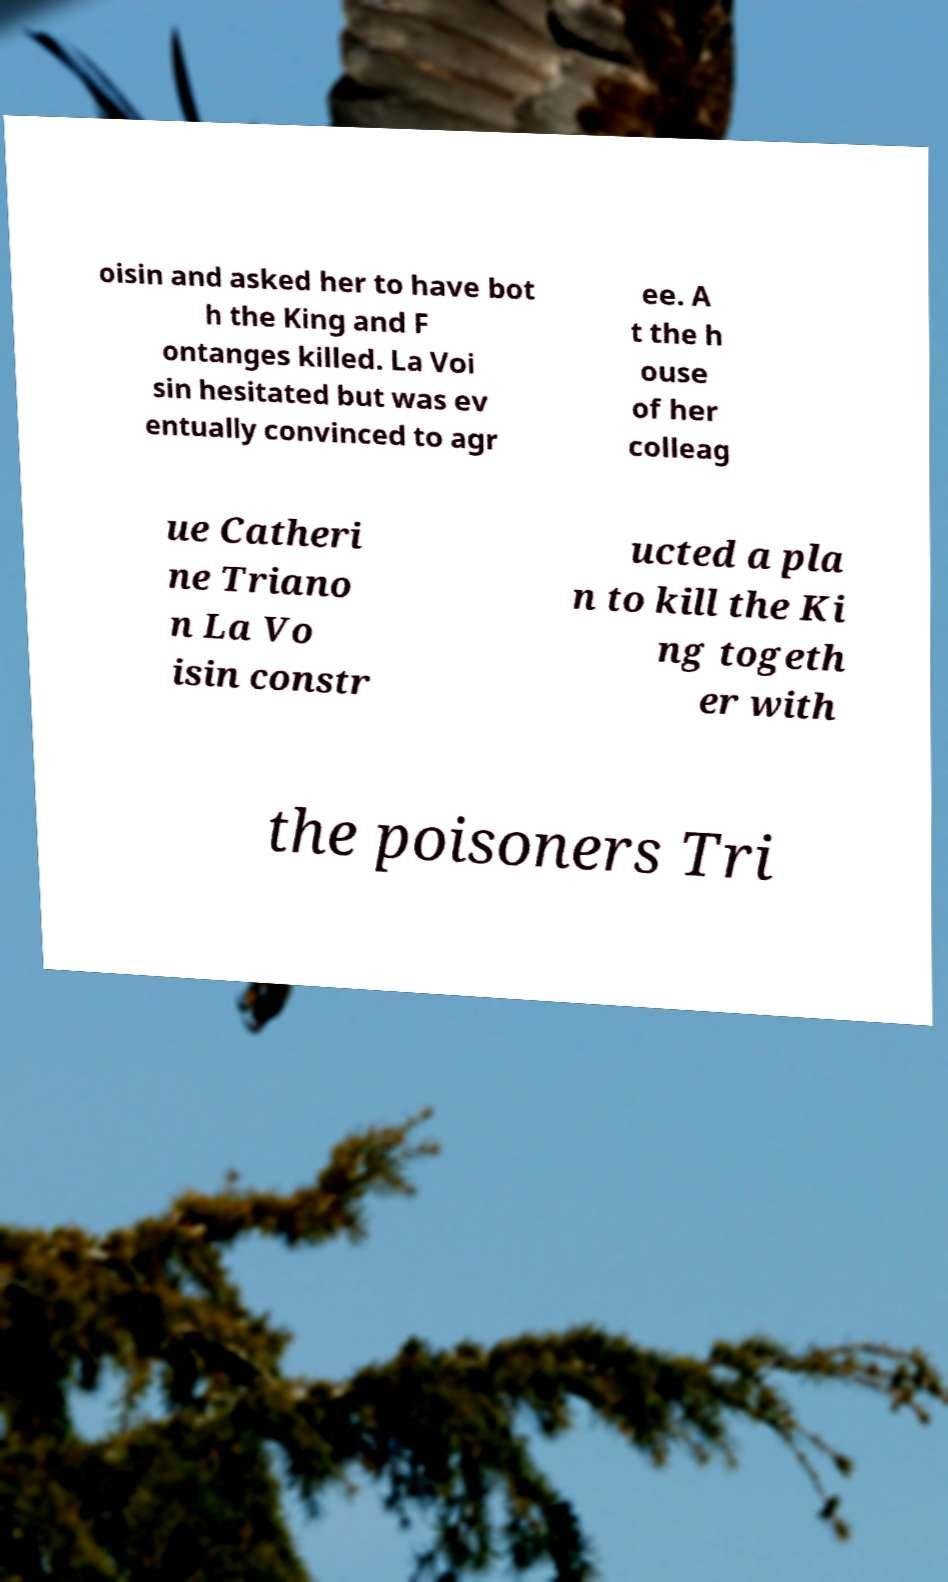What messages or text are displayed in this image? I need them in a readable, typed format. oisin and asked her to have bot h the King and F ontanges killed. La Voi sin hesitated but was ev entually convinced to agr ee. A t the h ouse of her colleag ue Catheri ne Triano n La Vo isin constr ucted a pla n to kill the Ki ng togeth er with the poisoners Tri 